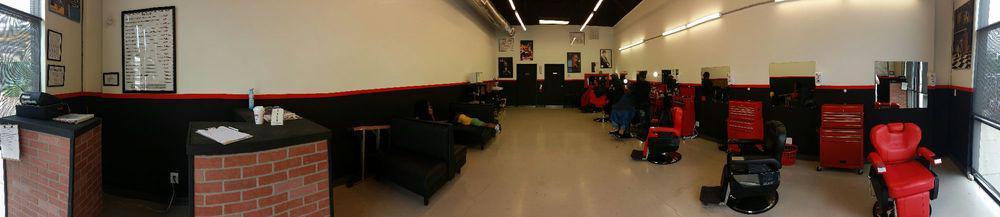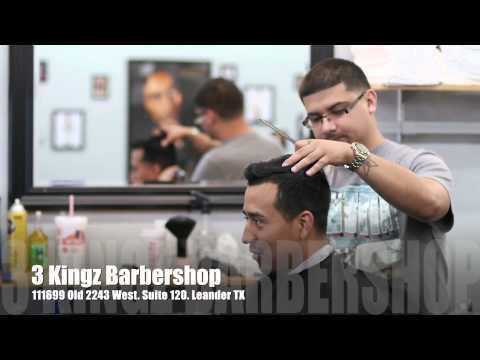The first image is the image on the left, the second image is the image on the right. Analyze the images presented: Is the assertion "An image shows a row of red and black barber chairs, without customers in the chairs in the foreground." valid? Answer yes or no. Yes. 